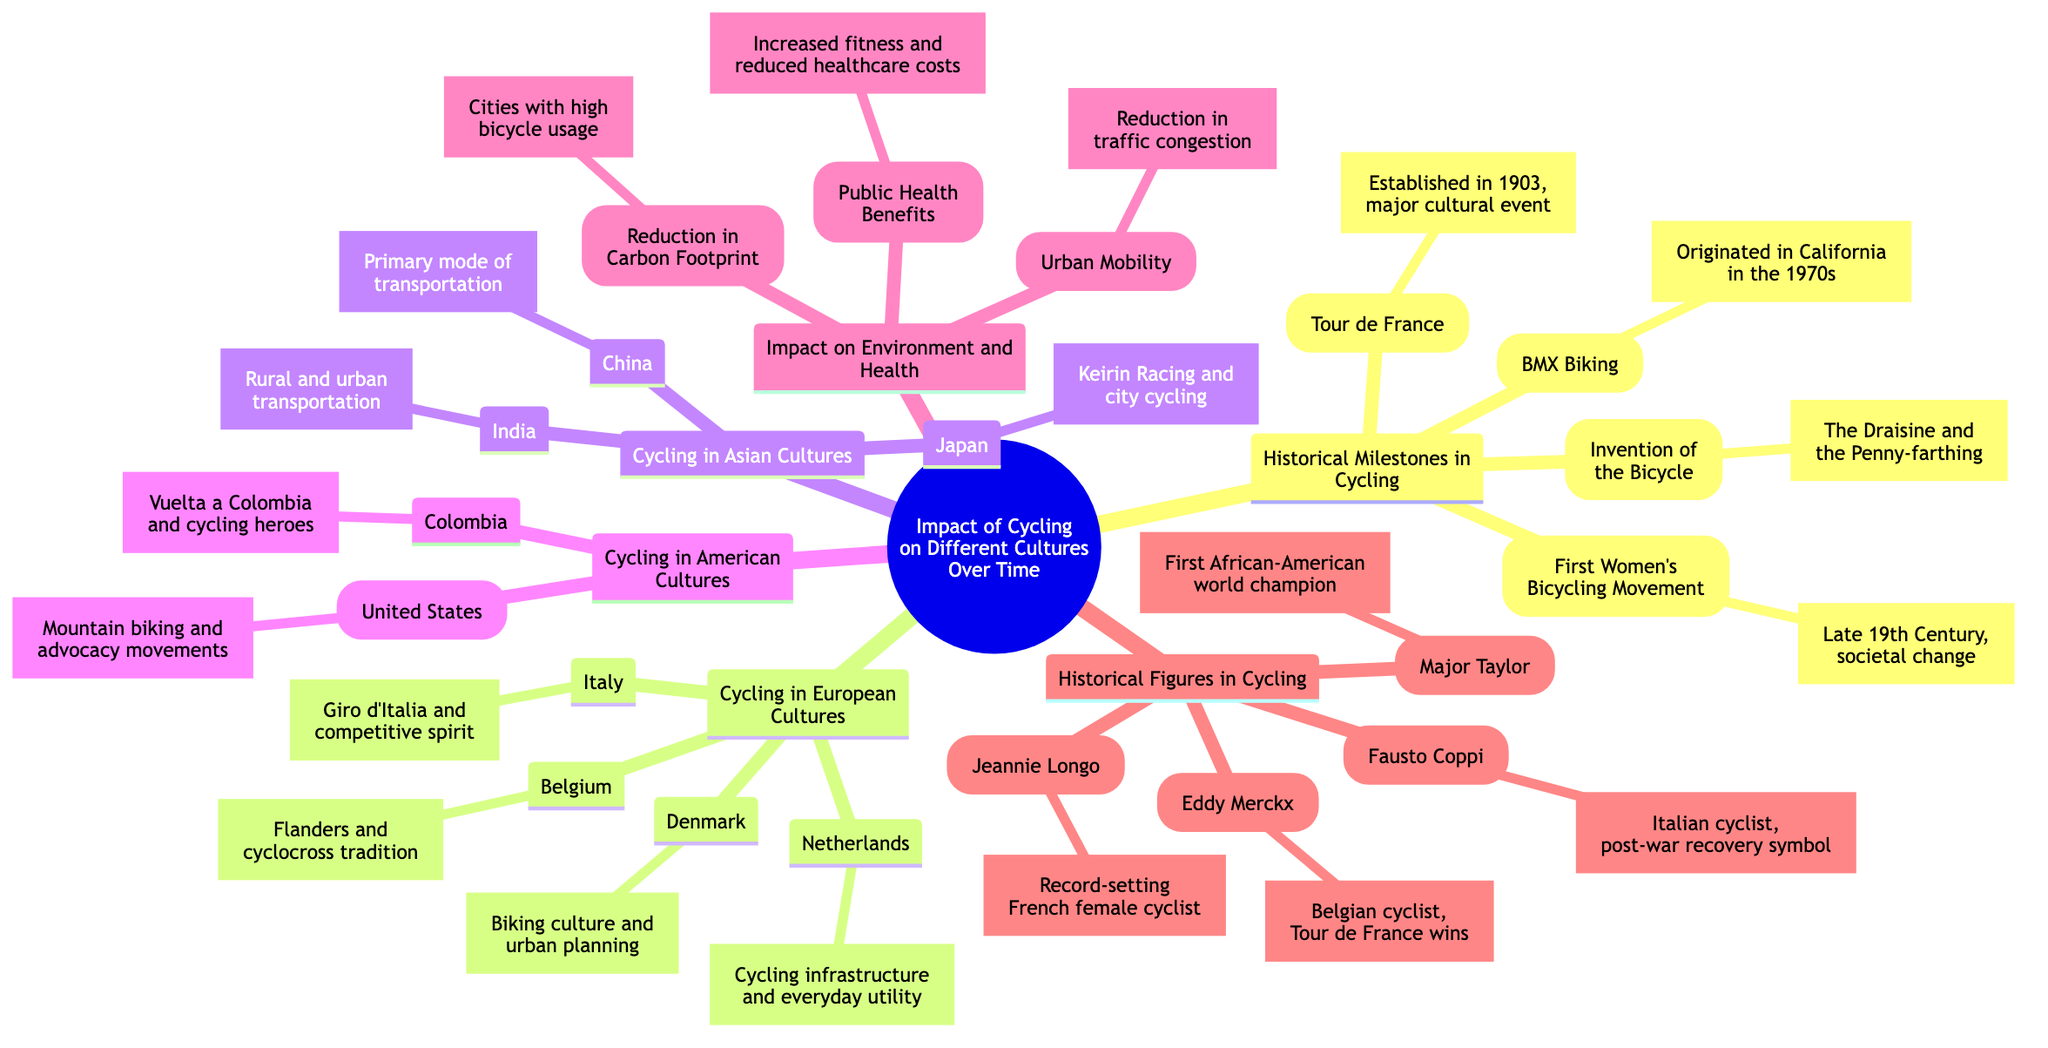What cultural event was established in 1903? The diagram indicates that the Tour de France was established in 1903 and is described as a major cultural event in France.
Answer: Tour de France Which country is associated with BMX Biking? The diagram shows that BMX Biking originated in California in the 1970s, which is a part of American culture. Therefore, California, within the context of America, is the connection.
Answer: California How many historical figures in cycling are listed? The diagram contains four historical figures in cycling: Eddy Merckx, Fausto Coppi, Jeannie Longo, and Major Taylor. Counting these figures gives a total of four.
Answer: 4 What symbolizes post-war recovery in Italy? The diagram indicates that Fausto Coppi, an Italian cyclist, is a symbol of post-war recovery. Therefore, the answer is directly linked to Coppi's significance.
Answer: Fausto Coppi Which country has a cycling culture linked to urban planning? In the diagram, Denmark is specifically mentioned in connection to biking culture and urban planning, indicating its cultural significance in this regard.
Answer: Denmark What is a primary mode of transportation in China? The diagram specifies that the bicycle serves as a primary mode of transportation in China, indicating its cultural and practical role within that society.
Answer: Bicycle What health benefit is related to increased fitness? According to the diagram, the public health benefits section indicates that increased fitness correlates with reduced healthcare costs. Thus, the health benefit is specified as public health benefits.
Answer: Public health benefits How many subcategories are under European cultures? The diagram indicates there are four subcategories listed under European cultures: Netherlands, Denmark, Italy, and Belgium. Thus, counting these areas, we arrive at four subcategories.
Answer: 4 What tradition is Belgium known for in cycling? The diagram states that Belgium has a tradition related to cyclocross, highlighting its cultural significance in the sport of cycling.
Answer: Cyclocross 